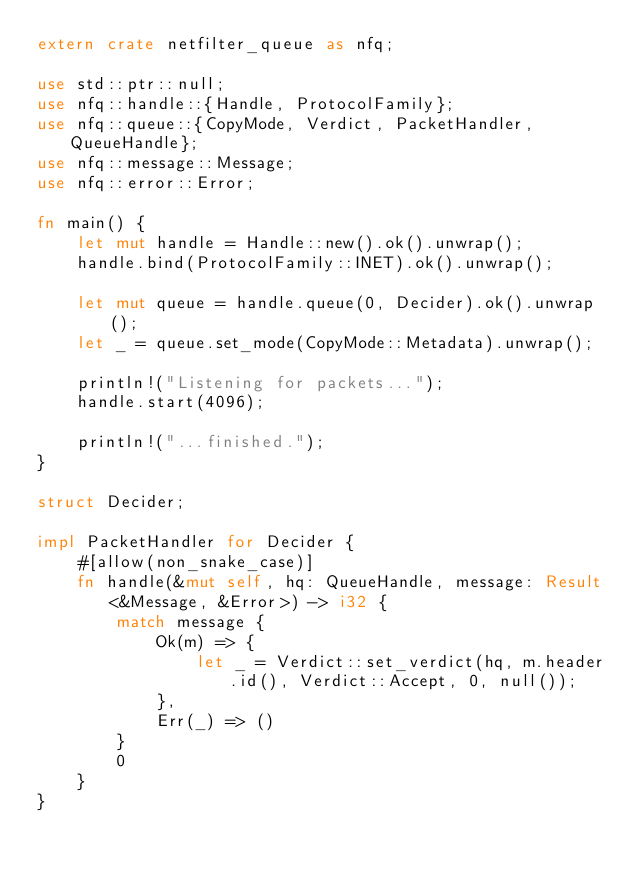Convert code to text. <code><loc_0><loc_0><loc_500><loc_500><_Rust_>extern crate netfilter_queue as nfq;

use std::ptr::null;
use nfq::handle::{Handle, ProtocolFamily};
use nfq::queue::{CopyMode, Verdict, PacketHandler, QueueHandle};
use nfq::message::Message;
use nfq::error::Error;

fn main() {
    let mut handle = Handle::new().ok().unwrap();
    handle.bind(ProtocolFamily::INET).ok().unwrap();

    let mut queue = handle.queue(0, Decider).ok().unwrap();
    let _ = queue.set_mode(CopyMode::Metadata).unwrap();

    println!("Listening for packets...");
    handle.start(4096);

    println!("...finished.");
}

struct Decider;

impl PacketHandler for Decider {
    #[allow(non_snake_case)]
    fn handle(&mut self, hq: QueueHandle, message: Result<&Message, &Error>) -> i32 {
        match message {
            Ok(m) => {
                let _ = Verdict::set_verdict(hq, m.header.id(), Verdict::Accept, 0, null());
            },
            Err(_) => ()
        }
        0
    }
}
</code> 